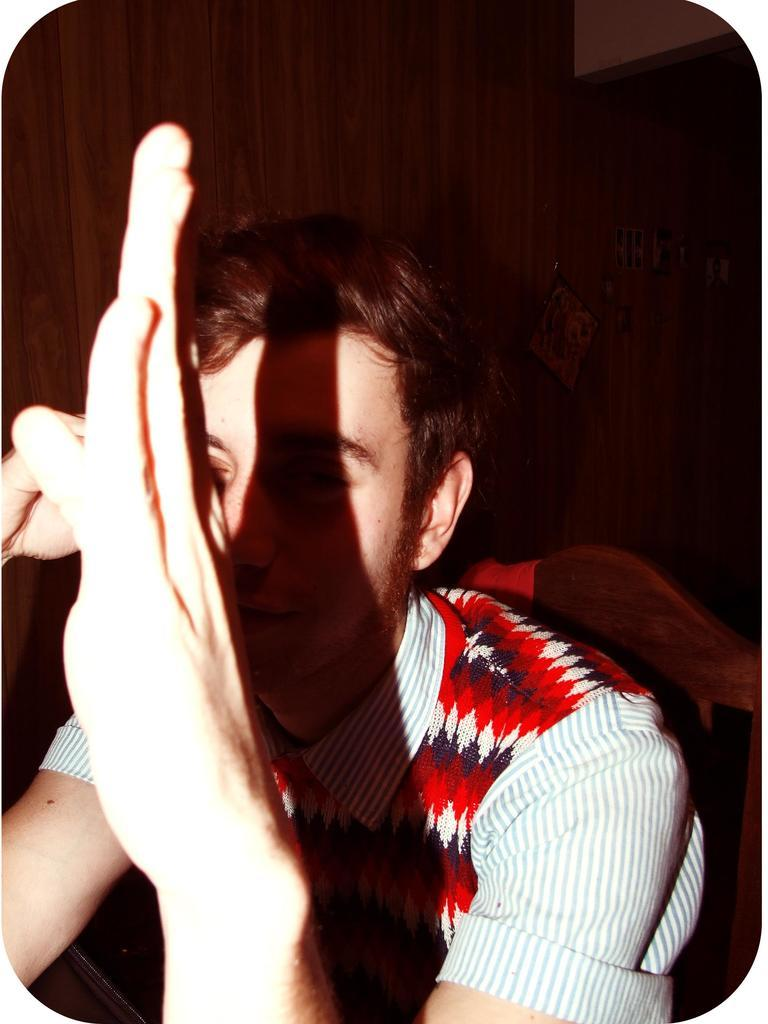What is the person in the image doing? The person is sitting on a chair in the image. What material can be seen at the back in the image? Wood is visible at the back in the image. Where is the nearest shop to the person in the image? There is no information about a shop or its location in the image. 